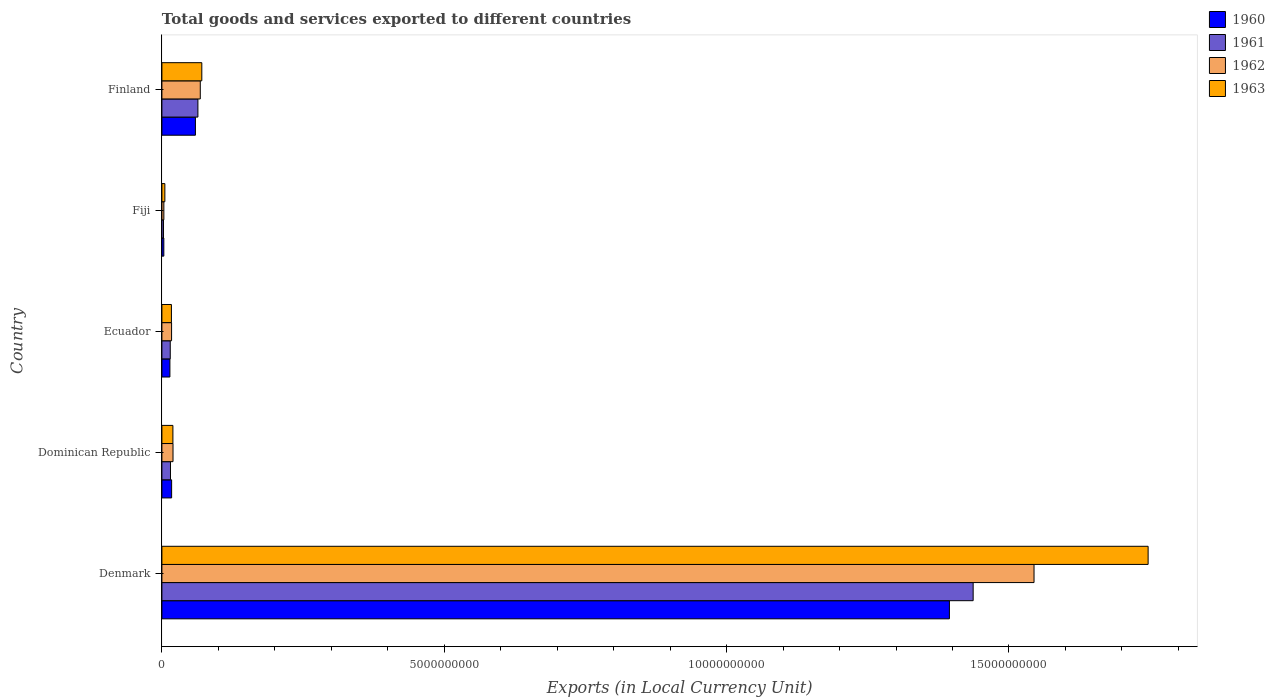How many different coloured bars are there?
Offer a terse response. 4. Are the number of bars per tick equal to the number of legend labels?
Your answer should be very brief. Yes. Are the number of bars on each tick of the Y-axis equal?
Offer a terse response. Yes. What is the label of the 1st group of bars from the top?
Provide a short and direct response. Finland. What is the Amount of goods and services exports in 1960 in Ecuador?
Make the answer very short. 1.42e+08. Across all countries, what is the maximum Amount of goods and services exports in 1963?
Ensure brevity in your answer.  1.75e+1. Across all countries, what is the minimum Amount of goods and services exports in 1962?
Your answer should be very brief. 3.48e+07. In which country was the Amount of goods and services exports in 1962 minimum?
Make the answer very short. Fiji. What is the total Amount of goods and services exports in 1960 in the graph?
Make the answer very short. 1.49e+1. What is the difference between the Amount of goods and services exports in 1962 in Denmark and that in Finland?
Give a very brief answer. 1.48e+1. What is the difference between the Amount of goods and services exports in 1963 in Fiji and the Amount of goods and services exports in 1962 in Finland?
Provide a short and direct response. -6.27e+08. What is the average Amount of goods and services exports in 1961 per country?
Your response must be concise. 3.07e+09. What is the difference between the Amount of goods and services exports in 1962 and Amount of goods and services exports in 1961 in Dominican Republic?
Your answer should be compact. 4.46e+07. In how many countries, is the Amount of goods and services exports in 1963 greater than 12000000000 LCU?
Your answer should be compact. 1. What is the ratio of the Amount of goods and services exports in 1960 in Denmark to that in Finland?
Provide a succinct answer. 23.5. Is the Amount of goods and services exports in 1962 in Dominican Republic less than that in Finland?
Keep it short and to the point. Yes. Is the difference between the Amount of goods and services exports in 1962 in Dominican Republic and Ecuador greater than the difference between the Amount of goods and services exports in 1961 in Dominican Republic and Ecuador?
Offer a terse response. Yes. What is the difference between the highest and the second highest Amount of goods and services exports in 1961?
Make the answer very short. 1.37e+1. What is the difference between the highest and the lowest Amount of goods and services exports in 1963?
Make the answer very short. 1.74e+1. In how many countries, is the Amount of goods and services exports in 1960 greater than the average Amount of goods and services exports in 1960 taken over all countries?
Provide a succinct answer. 1. Is the sum of the Amount of goods and services exports in 1963 in Dominican Republic and Finland greater than the maximum Amount of goods and services exports in 1960 across all countries?
Your response must be concise. No. Is it the case that in every country, the sum of the Amount of goods and services exports in 1960 and Amount of goods and services exports in 1961 is greater than the Amount of goods and services exports in 1963?
Provide a short and direct response. Yes. Are the values on the major ticks of X-axis written in scientific E-notation?
Offer a terse response. No. Does the graph contain grids?
Your answer should be compact. No. Where does the legend appear in the graph?
Ensure brevity in your answer.  Top right. What is the title of the graph?
Your answer should be very brief. Total goods and services exported to different countries. Does "1988" appear as one of the legend labels in the graph?
Keep it short and to the point. No. What is the label or title of the X-axis?
Give a very brief answer. Exports (in Local Currency Unit). What is the Exports (in Local Currency Unit) of 1960 in Denmark?
Keep it short and to the point. 1.39e+1. What is the Exports (in Local Currency Unit) in 1961 in Denmark?
Provide a succinct answer. 1.44e+1. What is the Exports (in Local Currency Unit) in 1962 in Denmark?
Offer a terse response. 1.54e+1. What is the Exports (in Local Currency Unit) in 1963 in Denmark?
Offer a terse response. 1.75e+1. What is the Exports (in Local Currency Unit) of 1960 in Dominican Republic?
Provide a short and direct response. 1.72e+08. What is the Exports (in Local Currency Unit) in 1961 in Dominican Republic?
Make the answer very short. 1.52e+08. What is the Exports (in Local Currency Unit) in 1962 in Dominican Republic?
Your response must be concise. 1.97e+08. What is the Exports (in Local Currency Unit) in 1963 in Dominican Republic?
Your answer should be compact. 1.95e+08. What is the Exports (in Local Currency Unit) in 1960 in Ecuador?
Your answer should be compact. 1.42e+08. What is the Exports (in Local Currency Unit) of 1961 in Ecuador?
Provide a succinct answer. 1.48e+08. What is the Exports (in Local Currency Unit) of 1962 in Ecuador?
Your answer should be very brief. 1.71e+08. What is the Exports (in Local Currency Unit) in 1963 in Ecuador?
Make the answer very short. 1.69e+08. What is the Exports (in Local Currency Unit) in 1960 in Fiji?
Ensure brevity in your answer.  3.40e+07. What is the Exports (in Local Currency Unit) of 1961 in Fiji?
Give a very brief answer. 2.85e+07. What is the Exports (in Local Currency Unit) of 1962 in Fiji?
Your answer should be very brief. 3.48e+07. What is the Exports (in Local Currency Unit) in 1963 in Fiji?
Your answer should be compact. 5.25e+07. What is the Exports (in Local Currency Unit) in 1960 in Finland?
Offer a terse response. 5.94e+08. What is the Exports (in Local Currency Unit) in 1961 in Finland?
Offer a terse response. 6.38e+08. What is the Exports (in Local Currency Unit) of 1962 in Finland?
Offer a terse response. 6.80e+08. What is the Exports (in Local Currency Unit) of 1963 in Finland?
Provide a succinct answer. 7.07e+08. Across all countries, what is the maximum Exports (in Local Currency Unit) of 1960?
Give a very brief answer. 1.39e+1. Across all countries, what is the maximum Exports (in Local Currency Unit) in 1961?
Your answer should be very brief. 1.44e+1. Across all countries, what is the maximum Exports (in Local Currency Unit) of 1962?
Provide a succinct answer. 1.54e+1. Across all countries, what is the maximum Exports (in Local Currency Unit) of 1963?
Offer a very short reply. 1.75e+1. Across all countries, what is the minimum Exports (in Local Currency Unit) of 1960?
Give a very brief answer. 3.40e+07. Across all countries, what is the minimum Exports (in Local Currency Unit) of 1961?
Provide a succinct answer. 2.85e+07. Across all countries, what is the minimum Exports (in Local Currency Unit) of 1962?
Provide a succinct answer. 3.48e+07. Across all countries, what is the minimum Exports (in Local Currency Unit) in 1963?
Keep it short and to the point. 5.25e+07. What is the total Exports (in Local Currency Unit) of 1960 in the graph?
Provide a succinct answer. 1.49e+1. What is the total Exports (in Local Currency Unit) in 1961 in the graph?
Offer a very short reply. 1.53e+1. What is the total Exports (in Local Currency Unit) of 1962 in the graph?
Your response must be concise. 1.65e+1. What is the total Exports (in Local Currency Unit) in 1963 in the graph?
Give a very brief answer. 1.86e+1. What is the difference between the Exports (in Local Currency Unit) in 1960 in Denmark and that in Dominican Republic?
Keep it short and to the point. 1.38e+1. What is the difference between the Exports (in Local Currency Unit) in 1961 in Denmark and that in Dominican Republic?
Offer a very short reply. 1.42e+1. What is the difference between the Exports (in Local Currency Unit) of 1962 in Denmark and that in Dominican Republic?
Make the answer very short. 1.52e+1. What is the difference between the Exports (in Local Currency Unit) of 1963 in Denmark and that in Dominican Republic?
Offer a terse response. 1.73e+1. What is the difference between the Exports (in Local Currency Unit) in 1960 in Denmark and that in Ecuador?
Your response must be concise. 1.38e+1. What is the difference between the Exports (in Local Currency Unit) of 1961 in Denmark and that in Ecuador?
Ensure brevity in your answer.  1.42e+1. What is the difference between the Exports (in Local Currency Unit) in 1962 in Denmark and that in Ecuador?
Ensure brevity in your answer.  1.53e+1. What is the difference between the Exports (in Local Currency Unit) in 1963 in Denmark and that in Ecuador?
Give a very brief answer. 1.73e+1. What is the difference between the Exports (in Local Currency Unit) of 1960 in Denmark and that in Fiji?
Offer a very short reply. 1.39e+1. What is the difference between the Exports (in Local Currency Unit) of 1961 in Denmark and that in Fiji?
Provide a short and direct response. 1.43e+1. What is the difference between the Exports (in Local Currency Unit) of 1962 in Denmark and that in Fiji?
Keep it short and to the point. 1.54e+1. What is the difference between the Exports (in Local Currency Unit) in 1963 in Denmark and that in Fiji?
Your answer should be compact. 1.74e+1. What is the difference between the Exports (in Local Currency Unit) of 1960 in Denmark and that in Finland?
Your answer should be compact. 1.34e+1. What is the difference between the Exports (in Local Currency Unit) of 1961 in Denmark and that in Finland?
Provide a succinct answer. 1.37e+1. What is the difference between the Exports (in Local Currency Unit) in 1962 in Denmark and that in Finland?
Make the answer very short. 1.48e+1. What is the difference between the Exports (in Local Currency Unit) in 1963 in Denmark and that in Finland?
Make the answer very short. 1.68e+1. What is the difference between the Exports (in Local Currency Unit) in 1960 in Dominican Republic and that in Ecuador?
Your answer should be compact. 3.03e+07. What is the difference between the Exports (in Local Currency Unit) in 1961 in Dominican Republic and that in Ecuador?
Offer a terse response. 4.14e+06. What is the difference between the Exports (in Local Currency Unit) in 1962 in Dominican Republic and that in Ecuador?
Your response must be concise. 2.53e+07. What is the difference between the Exports (in Local Currency Unit) in 1963 in Dominican Republic and that in Ecuador?
Provide a succinct answer. 2.64e+07. What is the difference between the Exports (in Local Currency Unit) in 1960 in Dominican Republic and that in Fiji?
Give a very brief answer. 1.38e+08. What is the difference between the Exports (in Local Currency Unit) of 1961 in Dominican Republic and that in Fiji?
Offer a very short reply. 1.24e+08. What is the difference between the Exports (in Local Currency Unit) in 1962 in Dominican Republic and that in Fiji?
Offer a very short reply. 1.62e+08. What is the difference between the Exports (in Local Currency Unit) in 1963 in Dominican Republic and that in Fiji?
Keep it short and to the point. 1.42e+08. What is the difference between the Exports (in Local Currency Unit) of 1960 in Dominican Republic and that in Finland?
Your answer should be very brief. -4.21e+08. What is the difference between the Exports (in Local Currency Unit) of 1961 in Dominican Republic and that in Finland?
Keep it short and to the point. -4.86e+08. What is the difference between the Exports (in Local Currency Unit) in 1962 in Dominican Republic and that in Finland?
Keep it short and to the point. -4.83e+08. What is the difference between the Exports (in Local Currency Unit) of 1963 in Dominican Republic and that in Finland?
Your response must be concise. -5.12e+08. What is the difference between the Exports (in Local Currency Unit) in 1960 in Ecuador and that in Fiji?
Make the answer very short. 1.08e+08. What is the difference between the Exports (in Local Currency Unit) in 1961 in Ecuador and that in Fiji?
Ensure brevity in your answer.  1.19e+08. What is the difference between the Exports (in Local Currency Unit) in 1962 in Ecuador and that in Fiji?
Ensure brevity in your answer.  1.37e+08. What is the difference between the Exports (in Local Currency Unit) in 1963 in Ecuador and that in Fiji?
Your answer should be compact. 1.16e+08. What is the difference between the Exports (in Local Currency Unit) in 1960 in Ecuador and that in Finland?
Your answer should be compact. -4.52e+08. What is the difference between the Exports (in Local Currency Unit) of 1961 in Ecuador and that in Finland?
Provide a succinct answer. -4.90e+08. What is the difference between the Exports (in Local Currency Unit) of 1962 in Ecuador and that in Finland?
Make the answer very short. -5.08e+08. What is the difference between the Exports (in Local Currency Unit) in 1963 in Ecuador and that in Finland?
Make the answer very short. -5.38e+08. What is the difference between the Exports (in Local Currency Unit) of 1960 in Fiji and that in Finland?
Your answer should be very brief. -5.60e+08. What is the difference between the Exports (in Local Currency Unit) in 1961 in Fiji and that in Finland?
Offer a terse response. -6.09e+08. What is the difference between the Exports (in Local Currency Unit) of 1962 in Fiji and that in Finland?
Give a very brief answer. -6.45e+08. What is the difference between the Exports (in Local Currency Unit) of 1963 in Fiji and that in Finland?
Make the answer very short. -6.54e+08. What is the difference between the Exports (in Local Currency Unit) of 1960 in Denmark and the Exports (in Local Currency Unit) of 1961 in Dominican Republic?
Your response must be concise. 1.38e+1. What is the difference between the Exports (in Local Currency Unit) in 1960 in Denmark and the Exports (in Local Currency Unit) in 1962 in Dominican Republic?
Ensure brevity in your answer.  1.37e+1. What is the difference between the Exports (in Local Currency Unit) of 1960 in Denmark and the Exports (in Local Currency Unit) of 1963 in Dominican Republic?
Ensure brevity in your answer.  1.38e+1. What is the difference between the Exports (in Local Currency Unit) in 1961 in Denmark and the Exports (in Local Currency Unit) in 1962 in Dominican Republic?
Offer a terse response. 1.42e+1. What is the difference between the Exports (in Local Currency Unit) of 1961 in Denmark and the Exports (in Local Currency Unit) of 1963 in Dominican Republic?
Provide a succinct answer. 1.42e+1. What is the difference between the Exports (in Local Currency Unit) in 1962 in Denmark and the Exports (in Local Currency Unit) in 1963 in Dominican Republic?
Ensure brevity in your answer.  1.52e+1. What is the difference between the Exports (in Local Currency Unit) in 1960 in Denmark and the Exports (in Local Currency Unit) in 1961 in Ecuador?
Provide a short and direct response. 1.38e+1. What is the difference between the Exports (in Local Currency Unit) in 1960 in Denmark and the Exports (in Local Currency Unit) in 1962 in Ecuador?
Your answer should be compact. 1.38e+1. What is the difference between the Exports (in Local Currency Unit) of 1960 in Denmark and the Exports (in Local Currency Unit) of 1963 in Ecuador?
Your answer should be compact. 1.38e+1. What is the difference between the Exports (in Local Currency Unit) in 1961 in Denmark and the Exports (in Local Currency Unit) in 1962 in Ecuador?
Offer a terse response. 1.42e+1. What is the difference between the Exports (in Local Currency Unit) in 1961 in Denmark and the Exports (in Local Currency Unit) in 1963 in Ecuador?
Your answer should be very brief. 1.42e+1. What is the difference between the Exports (in Local Currency Unit) in 1962 in Denmark and the Exports (in Local Currency Unit) in 1963 in Ecuador?
Ensure brevity in your answer.  1.53e+1. What is the difference between the Exports (in Local Currency Unit) of 1960 in Denmark and the Exports (in Local Currency Unit) of 1961 in Fiji?
Your answer should be very brief. 1.39e+1. What is the difference between the Exports (in Local Currency Unit) of 1960 in Denmark and the Exports (in Local Currency Unit) of 1962 in Fiji?
Your response must be concise. 1.39e+1. What is the difference between the Exports (in Local Currency Unit) of 1960 in Denmark and the Exports (in Local Currency Unit) of 1963 in Fiji?
Your answer should be very brief. 1.39e+1. What is the difference between the Exports (in Local Currency Unit) of 1961 in Denmark and the Exports (in Local Currency Unit) of 1962 in Fiji?
Make the answer very short. 1.43e+1. What is the difference between the Exports (in Local Currency Unit) in 1961 in Denmark and the Exports (in Local Currency Unit) in 1963 in Fiji?
Make the answer very short. 1.43e+1. What is the difference between the Exports (in Local Currency Unit) of 1962 in Denmark and the Exports (in Local Currency Unit) of 1963 in Fiji?
Your answer should be very brief. 1.54e+1. What is the difference between the Exports (in Local Currency Unit) in 1960 in Denmark and the Exports (in Local Currency Unit) in 1961 in Finland?
Provide a short and direct response. 1.33e+1. What is the difference between the Exports (in Local Currency Unit) of 1960 in Denmark and the Exports (in Local Currency Unit) of 1962 in Finland?
Ensure brevity in your answer.  1.33e+1. What is the difference between the Exports (in Local Currency Unit) in 1960 in Denmark and the Exports (in Local Currency Unit) in 1963 in Finland?
Keep it short and to the point. 1.32e+1. What is the difference between the Exports (in Local Currency Unit) of 1961 in Denmark and the Exports (in Local Currency Unit) of 1962 in Finland?
Your answer should be very brief. 1.37e+1. What is the difference between the Exports (in Local Currency Unit) in 1961 in Denmark and the Exports (in Local Currency Unit) in 1963 in Finland?
Your answer should be compact. 1.37e+1. What is the difference between the Exports (in Local Currency Unit) of 1962 in Denmark and the Exports (in Local Currency Unit) of 1963 in Finland?
Keep it short and to the point. 1.47e+1. What is the difference between the Exports (in Local Currency Unit) of 1960 in Dominican Republic and the Exports (in Local Currency Unit) of 1961 in Ecuador?
Ensure brevity in your answer.  2.41e+07. What is the difference between the Exports (in Local Currency Unit) of 1960 in Dominican Republic and the Exports (in Local Currency Unit) of 1962 in Ecuador?
Offer a very short reply. 6.92e+05. What is the difference between the Exports (in Local Currency Unit) in 1960 in Dominican Republic and the Exports (in Local Currency Unit) in 1963 in Ecuador?
Your response must be concise. 3.48e+06. What is the difference between the Exports (in Local Currency Unit) in 1961 in Dominican Republic and the Exports (in Local Currency Unit) in 1962 in Ecuador?
Make the answer very short. -1.93e+07. What is the difference between the Exports (in Local Currency Unit) in 1961 in Dominican Republic and the Exports (in Local Currency Unit) in 1963 in Ecuador?
Keep it short and to the point. -1.65e+07. What is the difference between the Exports (in Local Currency Unit) of 1962 in Dominican Republic and the Exports (in Local Currency Unit) of 1963 in Ecuador?
Keep it short and to the point. 2.81e+07. What is the difference between the Exports (in Local Currency Unit) of 1960 in Dominican Republic and the Exports (in Local Currency Unit) of 1961 in Fiji?
Offer a very short reply. 1.44e+08. What is the difference between the Exports (in Local Currency Unit) in 1960 in Dominican Republic and the Exports (in Local Currency Unit) in 1962 in Fiji?
Make the answer very short. 1.37e+08. What is the difference between the Exports (in Local Currency Unit) of 1960 in Dominican Republic and the Exports (in Local Currency Unit) of 1963 in Fiji?
Keep it short and to the point. 1.20e+08. What is the difference between the Exports (in Local Currency Unit) in 1961 in Dominican Republic and the Exports (in Local Currency Unit) in 1962 in Fiji?
Your answer should be very brief. 1.17e+08. What is the difference between the Exports (in Local Currency Unit) in 1961 in Dominican Republic and the Exports (in Local Currency Unit) in 1963 in Fiji?
Make the answer very short. 9.96e+07. What is the difference between the Exports (in Local Currency Unit) in 1962 in Dominican Republic and the Exports (in Local Currency Unit) in 1963 in Fiji?
Your response must be concise. 1.44e+08. What is the difference between the Exports (in Local Currency Unit) in 1960 in Dominican Republic and the Exports (in Local Currency Unit) in 1961 in Finland?
Provide a short and direct response. -4.66e+08. What is the difference between the Exports (in Local Currency Unit) of 1960 in Dominican Republic and the Exports (in Local Currency Unit) of 1962 in Finland?
Offer a terse response. -5.08e+08. What is the difference between the Exports (in Local Currency Unit) in 1960 in Dominican Republic and the Exports (in Local Currency Unit) in 1963 in Finland?
Give a very brief answer. -5.35e+08. What is the difference between the Exports (in Local Currency Unit) in 1961 in Dominican Republic and the Exports (in Local Currency Unit) in 1962 in Finland?
Offer a terse response. -5.28e+08. What is the difference between the Exports (in Local Currency Unit) in 1961 in Dominican Republic and the Exports (in Local Currency Unit) in 1963 in Finland?
Offer a very short reply. -5.55e+08. What is the difference between the Exports (in Local Currency Unit) of 1962 in Dominican Republic and the Exports (in Local Currency Unit) of 1963 in Finland?
Provide a short and direct response. -5.10e+08. What is the difference between the Exports (in Local Currency Unit) of 1960 in Ecuador and the Exports (in Local Currency Unit) of 1961 in Fiji?
Give a very brief answer. 1.13e+08. What is the difference between the Exports (in Local Currency Unit) in 1960 in Ecuador and the Exports (in Local Currency Unit) in 1962 in Fiji?
Your response must be concise. 1.07e+08. What is the difference between the Exports (in Local Currency Unit) of 1960 in Ecuador and the Exports (in Local Currency Unit) of 1963 in Fiji?
Your answer should be very brief. 8.93e+07. What is the difference between the Exports (in Local Currency Unit) in 1961 in Ecuador and the Exports (in Local Currency Unit) in 1962 in Fiji?
Make the answer very short. 1.13e+08. What is the difference between the Exports (in Local Currency Unit) in 1961 in Ecuador and the Exports (in Local Currency Unit) in 1963 in Fiji?
Keep it short and to the point. 9.55e+07. What is the difference between the Exports (in Local Currency Unit) in 1962 in Ecuador and the Exports (in Local Currency Unit) in 1963 in Fiji?
Keep it short and to the point. 1.19e+08. What is the difference between the Exports (in Local Currency Unit) of 1960 in Ecuador and the Exports (in Local Currency Unit) of 1961 in Finland?
Your response must be concise. -4.96e+08. What is the difference between the Exports (in Local Currency Unit) in 1960 in Ecuador and the Exports (in Local Currency Unit) in 1962 in Finland?
Offer a terse response. -5.38e+08. What is the difference between the Exports (in Local Currency Unit) in 1960 in Ecuador and the Exports (in Local Currency Unit) in 1963 in Finland?
Make the answer very short. -5.65e+08. What is the difference between the Exports (in Local Currency Unit) of 1961 in Ecuador and the Exports (in Local Currency Unit) of 1962 in Finland?
Your answer should be compact. -5.32e+08. What is the difference between the Exports (in Local Currency Unit) in 1961 in Ecuador and the Exports (in Local Currency Unit) in 1963 in Finland?
Your answer should be compact. -5.59e+08. What is the difference between the Exports (in Local Currency Unit) in 1962 in Ecuador and the Exports (in Local Currency Unit) in 1963 in Finland?
Ensure brevity in your answer.  -5.35e+08. What is the difference between the Exports (in Local Currency Unit) of 1960 in Fiji and the Exports (in Local Currency Unit) of 1961 in Finland?
Your answer should be very brief. -6.04e+08. What is the difference between the Exports (in Local Currency Unit) of 1960 in Fiji and the Exports (in Local Currency Unit) of 1962 in Finland?
Provide a succinct answer. -6.46e+08. What is the difference between the Exports (in Local Currency Unit) in 1960 in Fiji and the Exports (in Local Currency Unit) in 1963 in Finland?
Offer a very short reply. -6.73e+08. What is the difference between the Exports (in Local Currency Unit) in 1961 in Fiji and the Exports (in Local Currency Unit) in 1962 in Finland?
Provide a succinct answer. -6.51e+08. What is the difference between the Exports (in Local Currency Unit) in 1961 in Fiji and the Exports (in Local Currency Unit) in 1963 in Finland?
Offer a very short reply. -6.78e+08. What is the difference between the Exports (in Local Currency Unit) in 1962 in Fiji and the Exports (in Local Currency Unit) in 1963 in Finland?
Offer a terse response. -6.72e+08. What is the average Exports (in Local Currency Unit) of 1960 per country?
Provide a short and direct response. 2.98e+09. What is the average Exports (in Local Currency Unit) in 1961 per country?
Offer a terse response. 3.07e+09. What is the average Exports (in Local Currency Unit) in 1962 per country?
Offer a very short reply. 3.31e+09. What is the average Exports (in Local Currency Unit) in 1963 per country?
Make the answer very short. 3.72e+09. What is the difference between the Exports (in Local Currency Unit) in 1960 and Exports (in Local Currency Unit) in 1961 in Denmark?
Make the answer very short. -4.20e+08. What is the difference between the Exports (in Local Currency Unit) in 1960 and Exports (in Local Currency Unit) in 1962 in Denmark?
Keep it short and to the point. -1.50e+09. What is the difference between the Exports (in Local Currency Unit) of 1960 and Exports (in Local Currency Unit) of 1963 in Denmark?
Offer a terse response. -3.52e+09. What is the difference between the Exports (in Local Currency Unit) of 1961 and Exports (in Local Currency Unit) of 1962 in Denmark?
Provide a succinct answer. -1.08e+09. What is the difference between the Exports (in Local Currency Unit) in 1961 and Exports (in Local Currency Unit) in 1963 in Denmark?
Ensure brevity in your answer.  -3.10e+09. What is the difference between the Exports (in Local Currency Unit) in 1962 and Exports (in Local Currency Unit) in 1963 in Denmark?
Your answer should be very brief. -2.02e+09. What is the difference between the Exports (in Local Currency Unit) in 1960 and Exports (in Local Currency Unit) in 1961 in Dominican Republic?
Provide a short and direct response. 2.00e+07. What is the difference between the Exports (in Local Currency Unit) in 1960 and Exports (in Local Currency Unit) in 1962 in Dominican Republic?
Keep it short and to the point. -2.46e+07. What is the difference between the Exports (in Local Currency Unit) of 1960 and Exports (in Local Currency Unit) of 1963 in Dominican Republic?
Offer a terse response. -2.29e+07. What is the difference between the Exports (in Local Currency Unit) in 1961 and Exports (in Local Currency Unit) in 1962 in Dominican Republic?
Give a very brief answer. -4.46e+07. What is the difference between the Exports (in Local Currency Unit) of 1961 and Exports (in Local Currency Unit) of 1963 in Dominican Republic?
Your answer should be compact. -4.29e+07. What is the difference between the Exports (in Local Currency Unit) of 1962 and Exports (in Local Currency Unit) of 1963 in Dominican Republic?
Offer a very short reply. 1.70e+06. What is the difference between the Exports (in Local Currency Unit) of 1960 and Exports (in Local Currency Unit) of 1961 in Ecuador?
Your answer should be very brief. -6.14e+06. What is the difference between the Exports (in Local Currency Unit) of 1960 and Exports (in Local Currency Unit) of 1962 in Ecuador?
Keep it short and to the point. -2.96e+07. What is the difference between the Exports (in Local Currency Unit) in 1960 and Exports (in Local Currency Unit) in 1963 in Ecuador?
Your answer should be compact. -2.68e+07. What is the difference between the Exports (in Local Currency Unit) in 1961 and Exports (in Local Currency Unit) in 1962 in Ecuador?
Offer a terse response. -2.34e+07. What is the difference between the Exports (in Local Currency Unit) in 1961 and Exports (in Local Currency Unit) in 1963 in Ecuador?
Provide a short and direct response. -2.07e+07. What is the difference between the Exports (in Local Currency Unit) in 1962 and Exports (in Local Currency Unit) in 1963 in Ecuador?
Give a very brief answer. 2.79e+06. What is the difference between the Exports (in Local Currency Unit) in 1960 and Exports (in Local Currency Unit) in 1961 in Fiji?
Keep it short and to the point. 5.50e+06. What is the difference between the Exports (in Local Currency Unit) in 1960 and Exports (in Local Currency Unit) in 1962 in Fiji?
Your answer should be compact. -8.00e+05. What is the difference between the Exports (in Local Currency Unit) of 1960 and Exports (in Local Currency Unit) of 1963 in Fiji?
Keep it short and to the point. -1.85e+07. What is the difference between the Exports (in Local Currency Unit) in 1961 and Exports (in Local Currency Unit) in 1962 in Fiji?
Your answer should be compact. -6.30e+06. What is the difference between the Exports (in Local Currency Unit) of 1961 and Exports (in Local Currency Unit) of 1963 in Fiji?
Keep it short and to the point. -2.40e+07. What is the difference between the Exports (in Local Currency Unit) of 1962 and Exports (in Local Currency Unit) of 1963 in Fiji?
Make the answer very short. -1.77e+07. What is the difference between the Exports (in Local Currency Unit) of 1960 and Exports (in Local Currency Unit) of 1961 in Finland?
Offer a very short reply. -4.42e+07. What is the difference between the Exports (in Local Currency Unit) in 1960 and Exports (in Local Currency Unit) in 1962 in Finland?
Offer a terse response. -8.63e+07. What is the difference between the Exports (in Local Currency Unit) in 1960 and Exports (in Local Currency Unit) in 1963 in Finland?
Offer a very short reply. -1.13e+08. What is the difference between the Exports (in Local Currency Unit) of 1961 and Exports (in Local Currency Unit) of 1962 in Finland?
Keep it short and to the point. -4.21e+07. What is the difference between the Exports (in Local Currency Unit) in 1961 and Exports (in Local Currency Unit) in 1963 in Finland?
Your response must be concise. -6.91e+07. What is the difference between the Exports (in Local Currency Unit) of 1962 and Exports (in Local Currency Unit) of 1963 in Finland?
Ensure brevity in your answer.  -2.71e+07. What is the ratio of the Exports (in Local Currency Unit) of 1960 in Denmark to that in Dominican Republic?
Provide a short and direct response. 81.03. What is the ratio of the Exports (in Local Currency Unit) of 1961 in Denmark to that in Dominican Republic?
Make the answer very short. 94.45. What is the ratio of the Exports (in Local Currency Unit) of 1962 in Denmark to that in Dominican Republic?
Offer a terse response. 78.52. What is the ratio of the Exports (in Local Currency Unit) of 1963 in Denmark to that in Dominican Republic?
Give a very brief answer. 89.56. What is the ratio of the Exports (in Local Currency Unit) of 1960 in Denmark to that in Ecuador?
Keep it short and to the point. 98.34. What is the ratio of the Exports (in Local Currency Unit) of 1961 in Denmark to that in Ecuador?
Keep it short and to the point. 97.1. What is the ratio of the Exports (in Local Currency Unit) in 1962 in Denmark to that in Ecuador?
Your answer should be compact. 90.1. What is the ratio of the Exports (in Local Currency Unit) in 1963 in Denmark to that in Ecuador?
Make the answer very short. 103.58. What is the ratio of the Exports (in Local Currency Unit) of 1960 in Denmark to that in Fiji?
Your response must be concise. 410.18. What is the ratio of the Exports (in Local Currency Unit) in 1961 in Denmark to that in Fiji?
Give a very brief answer. 504.09. What is the ratio of the Exports (in Local Currency Unit) in 1962 in Denmark to that in Fiji?
Keep it short and to the point. 443.81. What is the ratio of the Exports (in Local Currency Unit) of 1963 in Denmark to that in Fiji?
Keep it short and to the point. 332.66. What is the ratio of the Exports (in Local Currency Unit) of 1960 in Denmark to that in Finland?
Give a very brief answer. 23.5. What is the ratio of the Exports (in Local Currency Unit) of 1961 in Denmark to that in Finland?
Offer a very short reply. 22.53. What is the ratio of the Exports (in Local Currency Unit) in 1962 in Denmark to that in Finland?
Your answer should be very brief. 22.72. What is the ratio of the Exports (in Local Currency Unit) in 1963 in Denmark to that in Finland?
Give a very brief answer. 24.71. What is the ratio of the Exports (in Local Currency Unit) in 1960 in Dominican Republic to that in Ecuador?
Give a very brief answer. 1.21. What is the ratio of the Exports (in Local Currency Unit) of 1961 in Dominican Republic to that in Ecuador?
Make the answer very short. 1.03. What is the ratio of the Exports (in Local Currency Unit) of 1962 in Dominican Republic to that in Ecuador?
Provide a succinct answer. 1.15. What is the ratio of the Exports (in Local Currency Unit) of 1963 in Dominican Republic to that in Ecuador?
Make the answer very short. 1.16. What is the ratio of the Exports (in Local Currency Unit) of 1960 in Dominican Republic to that in Fiji?
Provide a short and direct response. 5.06. What is the ratio of the Exports (in Local Currency Unit) of 1961 in Dominican Republic to that in Fiji?
Make the answer very short. 5.34. What is the ratio of the Exports (in Local Currency Unit) in 1962 in Dominican Republic to that in Fiji?
Your answer should be very brief. 5.65. What is the ratio of the Exports (in Local Currency Unit) of 1963 in Dominican Republic to that in Fiji?
Ensure brevity in your answer.  3.71. What is the ratio of the Exports (in Local Currency Unit) in 1960 in Dominican Republic to that in Finland?
Offer a very short reply. 0.29. What is the ratio of the Exports (in Local Currency Unit) in 1961 in Dominican Republic to that in Finland?
Your response must be concise. 0.24. What is the ratio of the Exports (in Local Currency Unit) of 1962 in Dominican Republic to that in Finland?
Your answer should be compact. 0.29. What is the ratio of the Exports (in Local Currency Unit) in 1963 in Dominican Republic to that in Finland?
Provide a short and direct response. 0.28. What is the ratio of the Exports (in Local Currency Unit) in 1960 in Ecuador to that in Fiji?
Your response must be concise. 4.17. What is the ratio of the Exports (in Local Currency Unit) in 1961 in Ecuador to that in Fiji?
Your answer should be very brief. 5.19. What is the ratio of the Exports (in Local Currency Unit) in 1962 in Ecuador to that in Fiji?
Ensure brevity in your answer.  4.93. What is the ratio of the Exports (in Local Currency Unit) in 1963 in Ecuador to that in Fiji?
Ensure brevity in your answer.  3.21. What is the ratio of the Exports (in Local Currency Unit) in 1960 in Ecuador to that in Finland?
Provide a succinct answer. 0.24. What is the ratio of the Exports (in Local Currency Unit) of 1961 in Ecuador to that in Finland?
Offer a terse response. 0.23. What is the ratio of the Exports (in Local Currency Unit) of 1962 in Ecuador to that in Finland?
Give a very brief answer. 0.25. What is the ratio of the Exports (in Local Currency Unit) in 1963 in Ecuador to that in Finland?
Give a very brief answer. 0.24. What is the ratio of the Exports (in Local Currency Unit) in 1960 in Fiji to that in Finland?
Make the answer very short. 0.06. What is the ratio of the Exports (in Local Currency Unit) of 1961 in Fiji to that in Finland?
Give a very brief answer. 0.04. What is the ratio of the Exports (in Local Currency Unit) in 1962 in Fiji to that in Finland?
Give a very brief answer. 0.05. What is the ratio of the Exports (in Local Currency Unit) in 1963 in Fiji to that in Finland?
Provide a succinct answer. 0.07. What is the difference between the highest and the second highest Exports (in Local Currency Unit) of 1960?
Keep it short and to the point. 1.34e+1. What is the difference between the highest and the second highest Exports (in Local Currency Unit) in 1961?
Keep it short and to the point. 1.37e+1. What is the difference between the highest and the second highest Exports (in Local Currency Unit) of 1962?
Offer a terse response. 1.48e+1. What is the difference between the highest and the second highest Exports (in Local Currency Unit) of 1963?
Your answer should be very brief. 1.68e+1. What is the difference between the highest and the lowest Exports (in Local Currency Unit) in 1960?
Ensure brevity in your answer.  1.39e+1. What is the difference between the highest and the lowest Exports (in Local Currency Unit) in 1961?
Offer a terse response. 1.43e+1. What is the difference between the highest and the lowest Exports (in Local Currency Unit) in 1962?
Ensure brevity in your answer.  1.54e+1. What is the difference between the highest and the lowest Exports (in Local Currency Unit) of 1963?
Provide a short and direct response. 1.74e+1. 